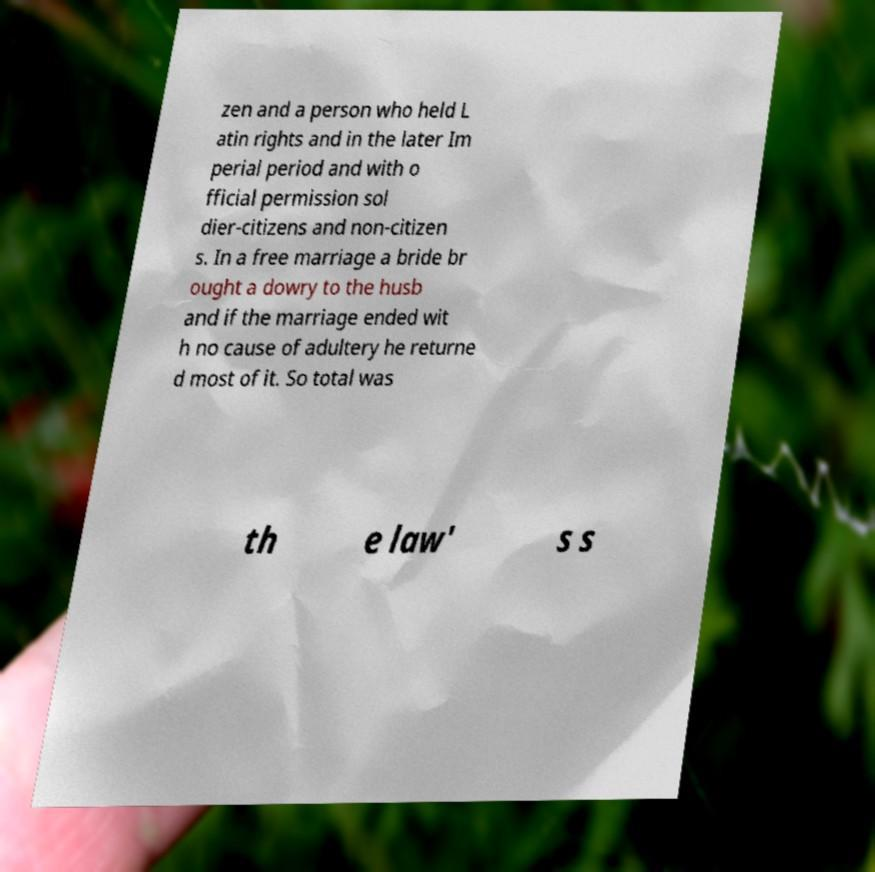There's text embedded in this image that I need extracted. Can you transcribe it verbatim? zen and a person who held L atin rights and in the later Im perial period and with o fficial permission sol dier-citizens and non-citizen s. In a free marriage a bride br ought a dowry to the husb and if the marriage ended wit h no cause of adultery he returne d most of it. So total was th e law' s s 